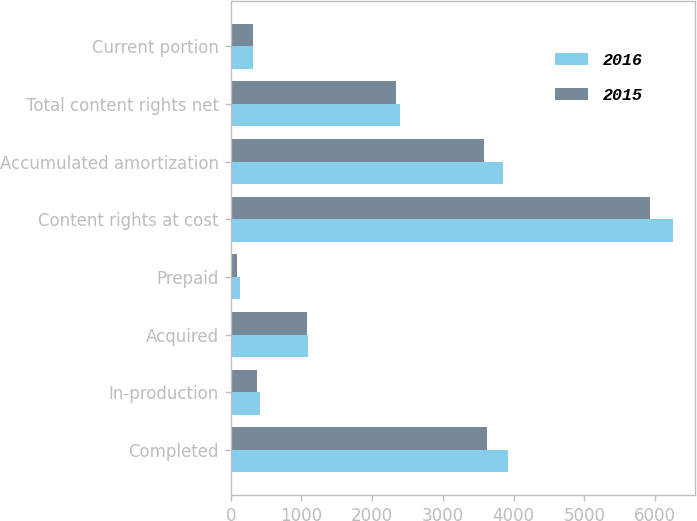<chart> <loc_0><loc_0><loc_500><loc_500><stacked_bar_chart><ecel><fcel>Completed<fcel>In-production<fcel>Acquired<fcel>Prepaid<fcel>Content rights at cost<fcel>Accumulated amortization<fcel>Total content rights net<fcel>Current portion<nl><fcel>2016<fcel>3920<fcel>420<fcel>1090<fcel>129<fcel>6248<fcel>3849<fcel>2399<fcel>310<nl><fcel>2015<fcel>3624<fcel>376<fcel>1078<fcel>96<fcel>5927<fcel>3584<fcel>2343<fcel>313<nl></chart> 